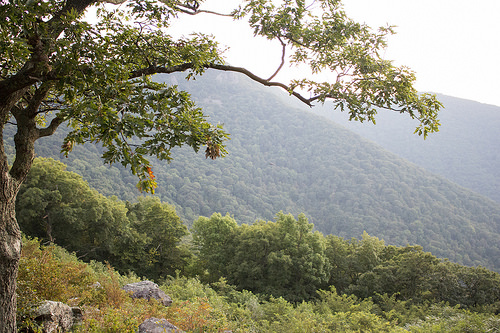<image>
Can you confirm if the tree is on the forest? No. The tree is not positioned on the forest. They may be near each other, but the tree is not supported by or resting on top of the forest. 